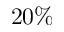<formula> <loc_0><loc_0><loc_500><loc_500>2 0 \%</formula> 